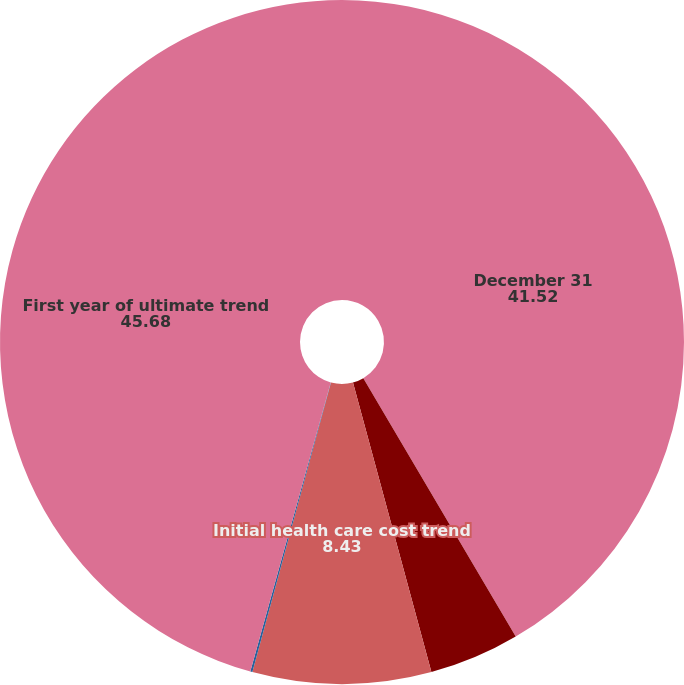<chart> <loc_0><loc_0><loc_500><loc_500><pie_chart><fcel>December 31<fcel>Discount rate<fcel>Initial health care cost trend<fcel>Ultimate health care cost<fcel>First year of ultimate trend<nl><fcel>41.52%<fcel>4.27%<fcel>8.43%<fcel>0.1%<fcel>45.68%<nl></chart> 